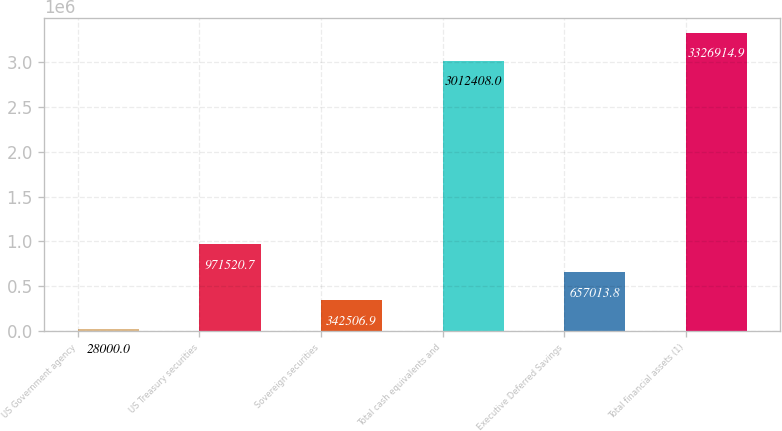Convert chart to OTSL. <chart><loc_0><loc_0><loc_500><loc_500><bar_chart><fcel>US Government agency<fcel>US Treasury securities<fcel>Sovereign securities<fcel>Total cash equivalents and<fcel>Executive Deferred Savings<fcel>Total financial assets (1)<nl><fcel>28000<fcel>971521<fcel>342507<fcel>3.01241e+06<fcel>657014<fcel>3.32691e+06<nl></chart> 